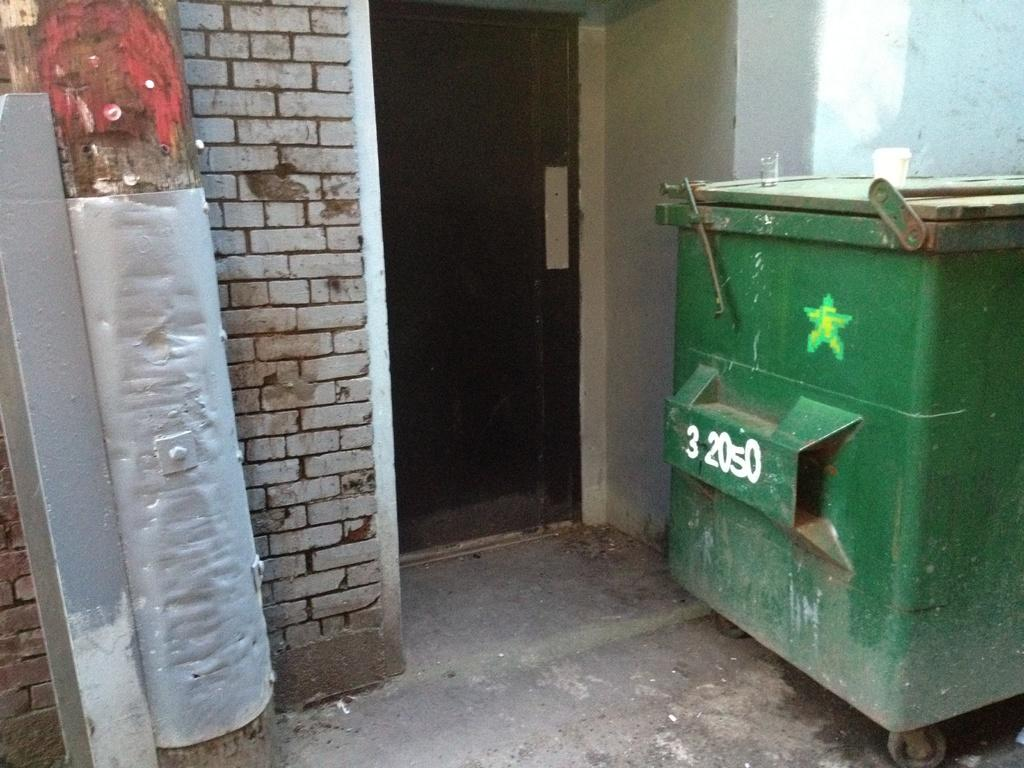What color is the trash bin in the image? The trash bin in the image is green. Where is the trash bin located in the image? The trash bin is on the right side of the image. What other structures can be seen in the image? There is a wall and a door visible in the image. Where is the kettle located in the image? There is no kettle present in the image. 